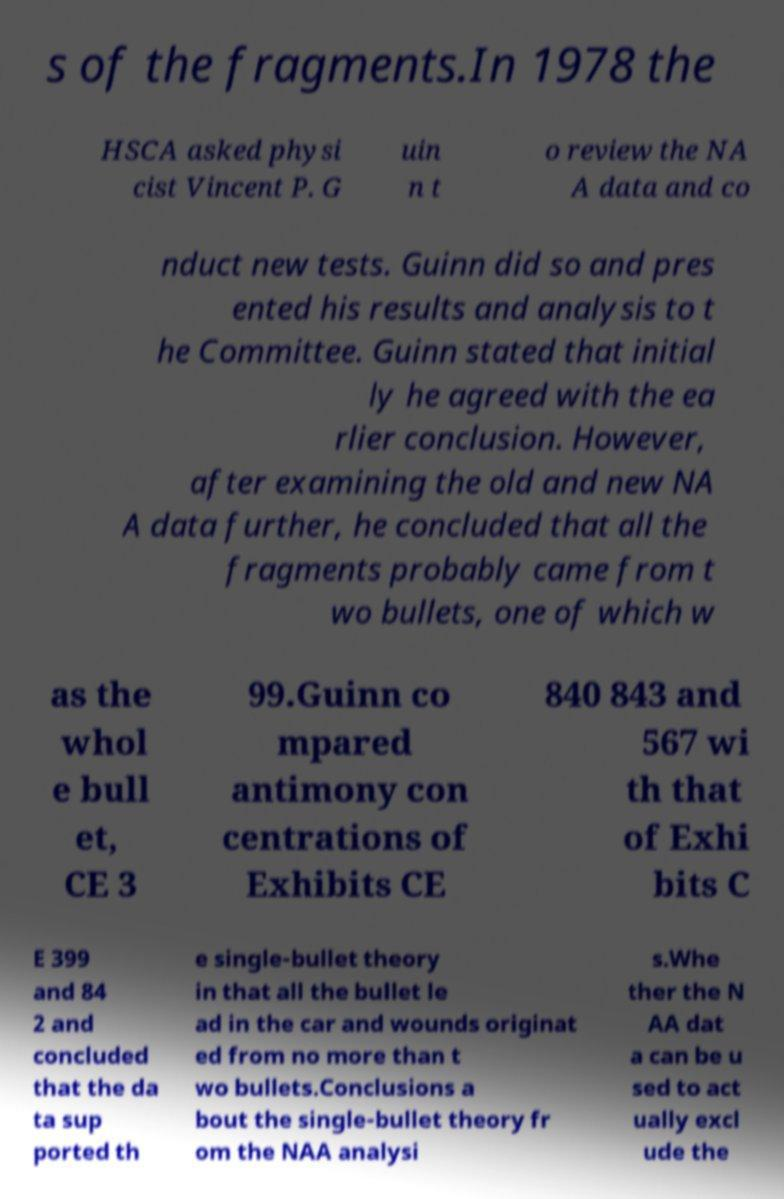Could you assist in decoding the text presented in this image and type it out clearly? s of the fragments.In 1978 the HSCA asked physi cist Vincent P. G uin n t o review the NA A data and co nduct new tests. Guinn did so and pres ented his results and analysis to t he Committee. Guinn stated that initial ly he agreed with the ea rlier conclusion. However, after examining the old and new NA A data further, he concluded that all the fragments probably came from t wo bullets, one of which w as the whol e bull et, CE 3 99.Guinn co mpared antimony con centrations of Exhibits CE 840 843 and 567 wi th that of Exhi bits C E 399 and 84 2 and concluded that the da ta sup ported th e single-bullet theory in that all the bullet le ad in the car and wounds originat ed from no more than t wo bullets.Conclusions a bout the single-bullet theory fr om the NAA analysi s.Whe ther the N AA dat a can be u sed to act ually excl ude the 